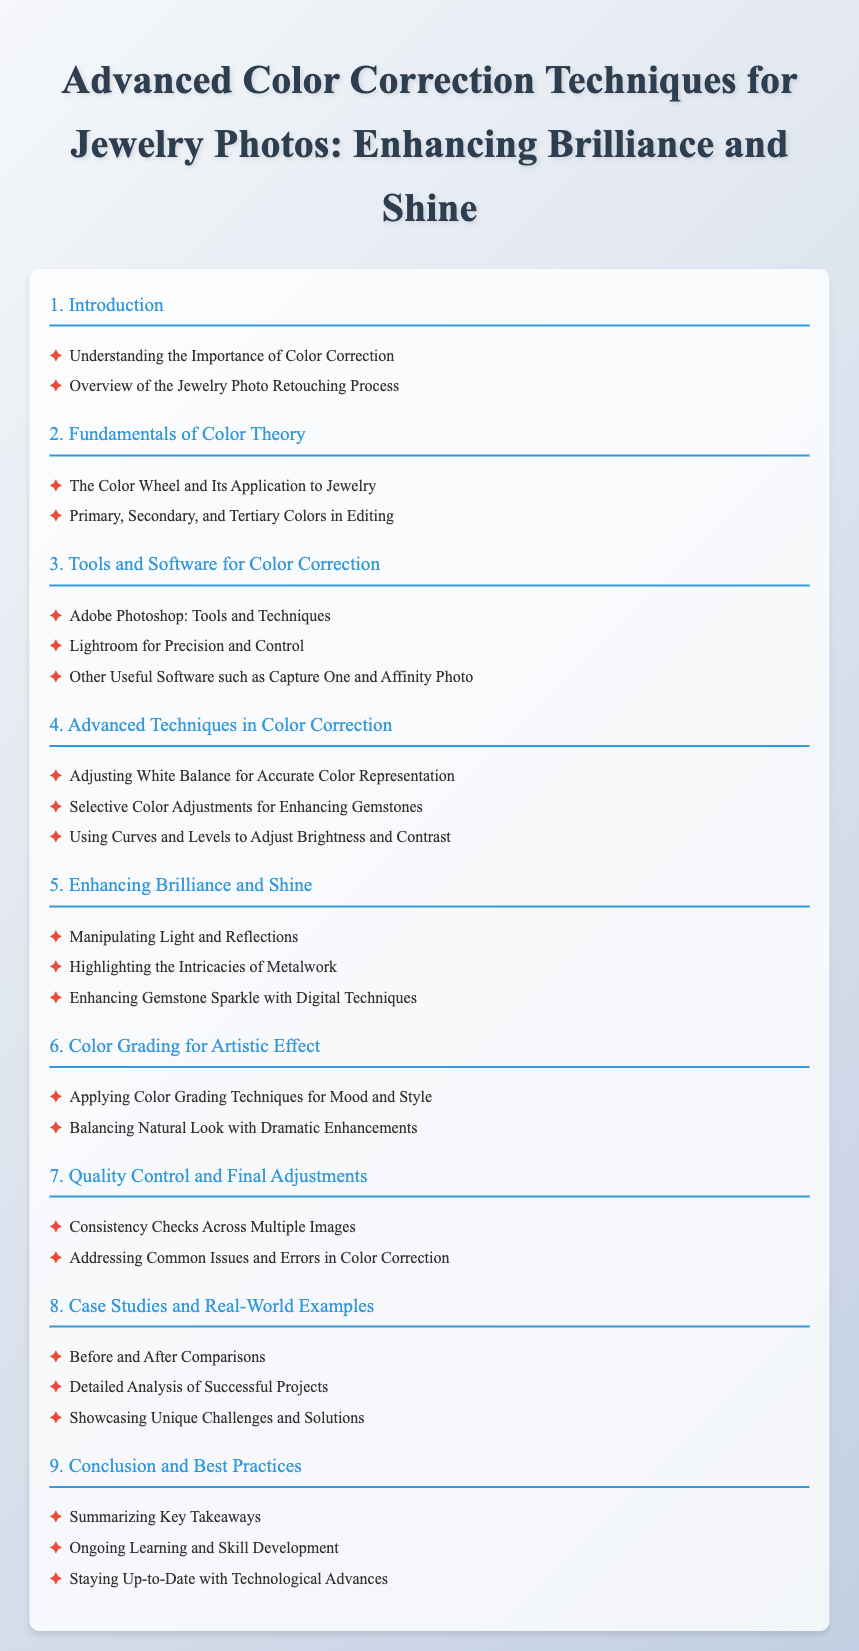What is the title of the document? The title is the main heading of the document, found at the top of the page.
Answer: Advanced Color Correction Techniques for Jewelry Photos: Enhancing Brilliance and Shine How many chapters are in the document? The number of chapters includes all sections listed in the table of contents.
Answer: 9 What chapter discusses color theory? This chapter is focused on the fundamental concepts of color as they relate to jewelry.
Answer: Fundamentals of Color Theory Which software is mentioned for precision and control? This software is highlighted for its capabilities in color correction.
Answer: Lightroom What is included in Chapter 5? This chapter encompasses techniques specifically focused on enhancing the visual appeal of jewelry.
Answer: Enhancing Brilliance and Shine What is a focus of the Introduction chapter? This section aims to provide foundational insights into color correction for jewelry photos.
Answer: Understanding the Importance of Color Correction Which chapter contains before and after comparisons? This is a specific study area illustrating the impacts of color correction techniques on jewelry photos.
Answer: Case Studies and Real-World Examples What does Chapter 6 emphasize? This chapter discusses how coloring techniques can be utilized creatively in photo retouching.
Answer: Color Grading for Artistic Effect What type of adjustments does Chapter 7 cover? This chapter deals with refining images post-editing to ensure quality.
Answer: Final Adjustments 